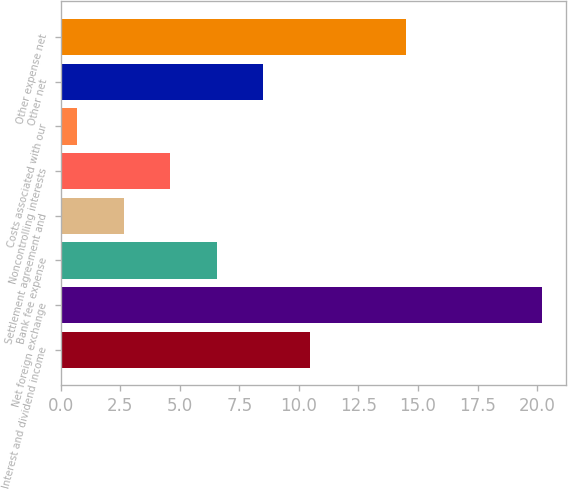Convert chart. <chart><loc_0><loc_0><loc_500><loc_500><bar_chart><fcel>Interest and dividend income<fcel>Net foreign exchange<fcel>Bank fee expense<fcel>Settlement agreement and<fcel>Noncontrolling interests<fcel>Costs associated with our<fcel>Other net<fcel>Other expense net<nl><fcel>10.45<fcel>20.2<fcel>6.55<fcel>2.65<fcel>4.6<fcel>0.7<fcel>8.5<fcel>14.5<nl></chart> 